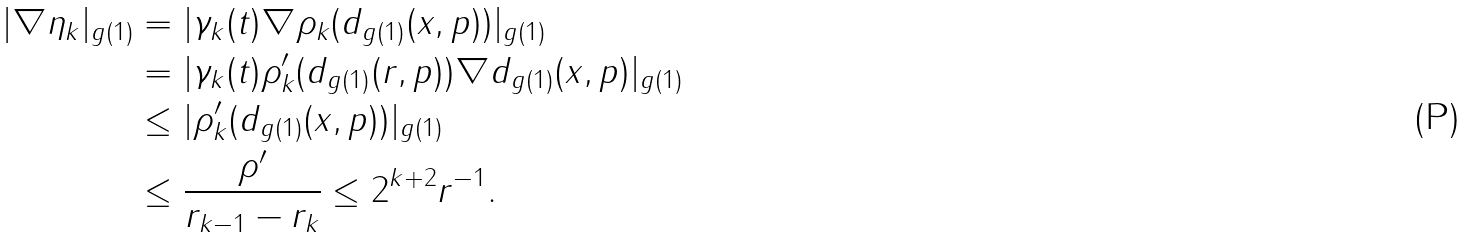Convert formula to latex. <formula><loc_0><loc_0><loc_500><loc_500>| \nabla \eta _ { k } | _ { g ( 1 ) } & = | \gamma _ { k } ( t ) \nabla \rho _ { k } ( d _ { g ( 1 ) } ( x , p ) ) | _ { g ( 1 ) } \\ & = | \gamma _ { k } ( t ) \rho _ { k } ^ { \prime } ( d _ { g ( 1 ) } ( r , p ) ) \nabla d _ { g ( 1 ) } ( x , p ) | _ { g ( 1 ) } \\ & \leq | \rho _ { k } ^ { \prime } ( d _ { g ( 1 ) } ( x , p ) ) | _ { g ( 1 ) } \\ & \leq \frac { \rho ^ { \prime } } { r _ { k - 1 } - r _ { k } } \leq 2 ^ { k + 2 } r ^ { - 1 } .</formula> 